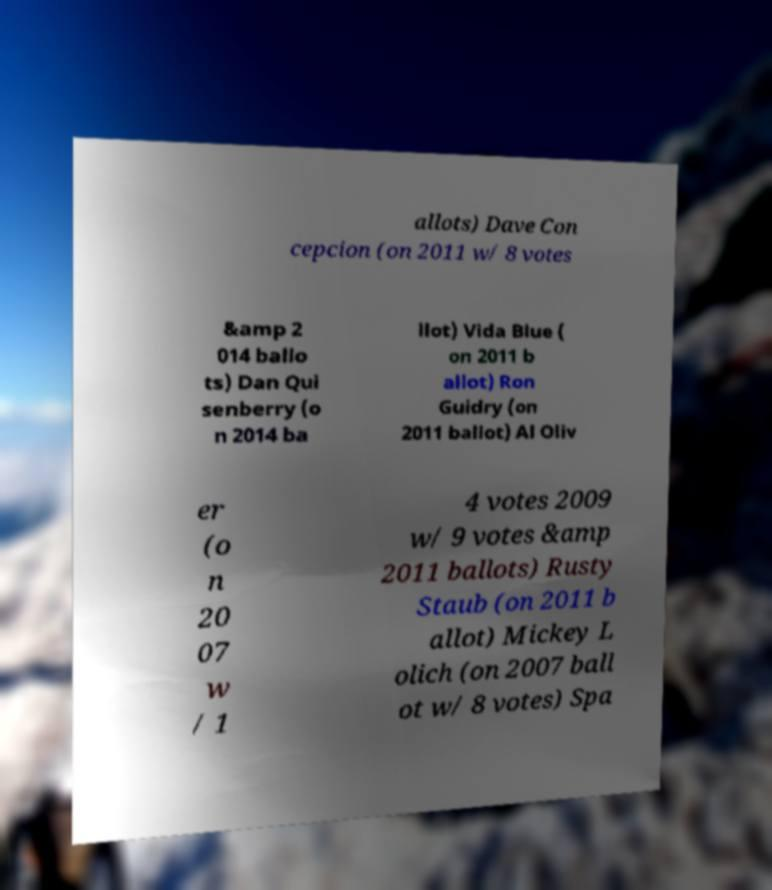Please read and relay the text visible in this image. What does it say? allots) Dave Con cepcion (on 2011 w/ 8 votes &amp 2 014 ballo ts) Dan Qui senberry (o n 2014 ba llot) Vida Blue ( on 2011 b allot) Ron Guidry (on 2011 ballot) Al Oliv er (o n 20 07 w / 1 4 votes 2009 w/ 9 votes &amp 2011 ballots) Rusty Staub (on 2011 b allot) Mickey L olich (on 2007 ball ot w/ 8 votes) Spa 